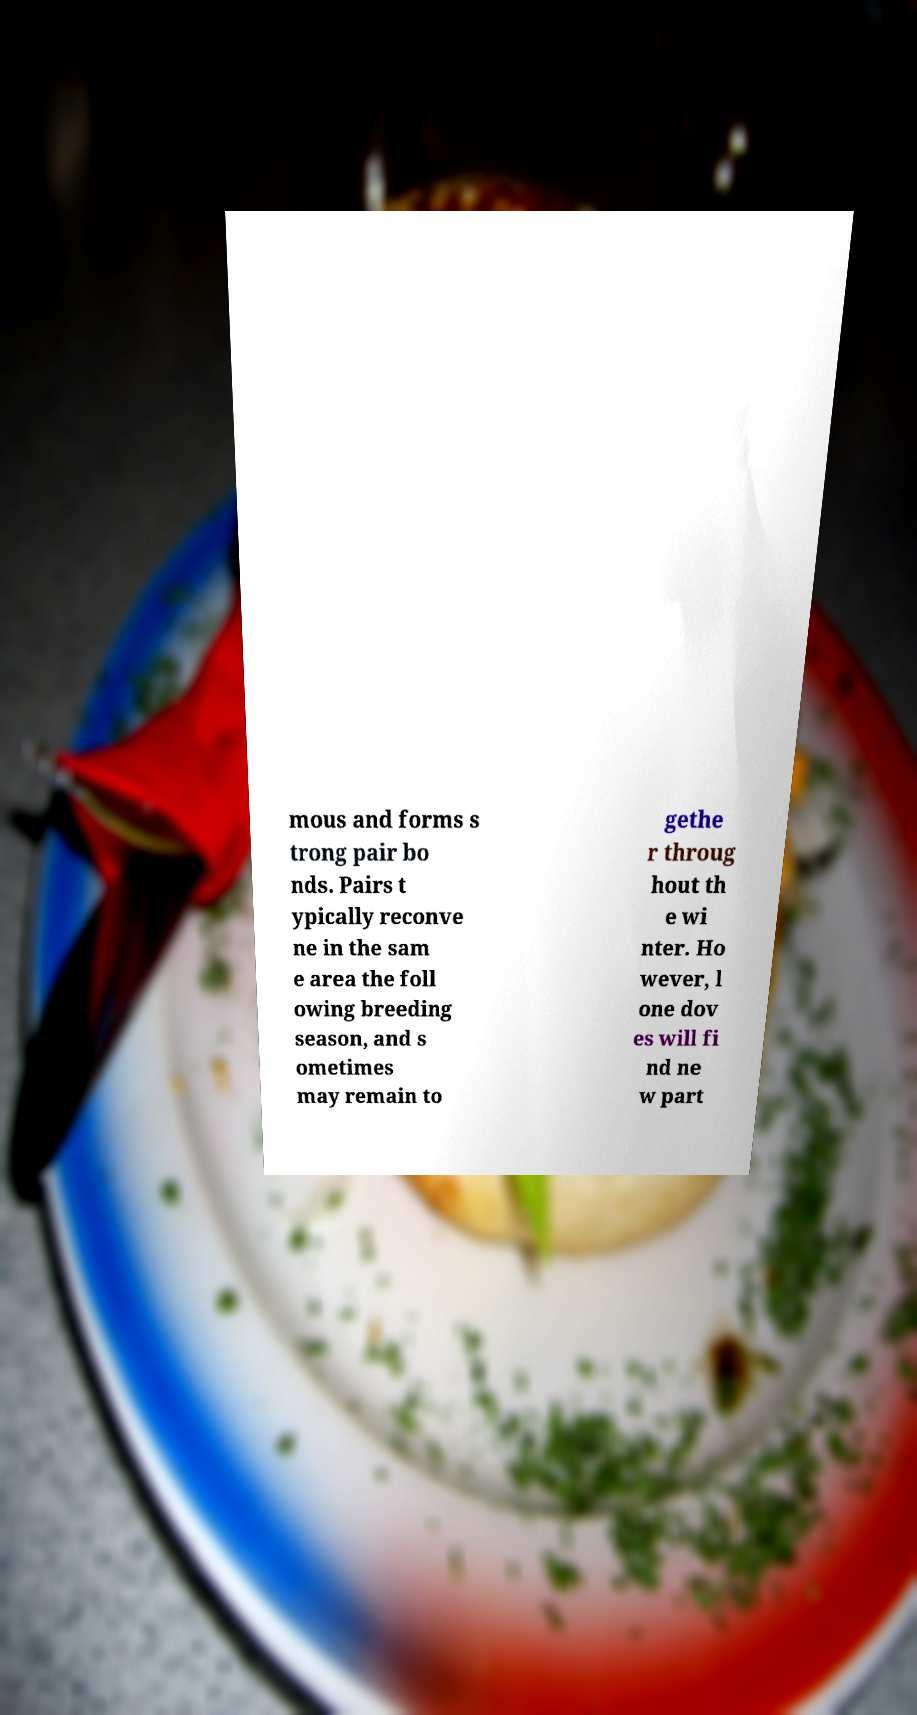Please identify and transcribe the text found in this image. mous and forms s trong pair bo nds. Pairs t ypically reconve ne in the sam e area the foll owing breeding season, and s ometimes may remain to gethe r throug hout th e wi nter. Ho wever, l one dov es will fi nd ne w part 